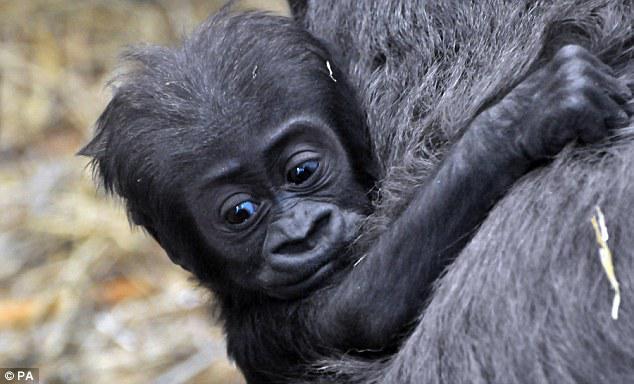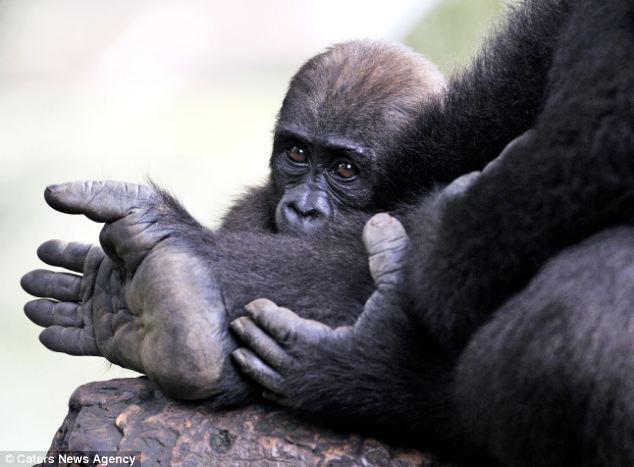The first image is the image on the left, the second image is the image on the right. Assess this claim about the two images: "A mother gorilla is holding her infant on one arm". Correct or not? Answer yes or no. No. 